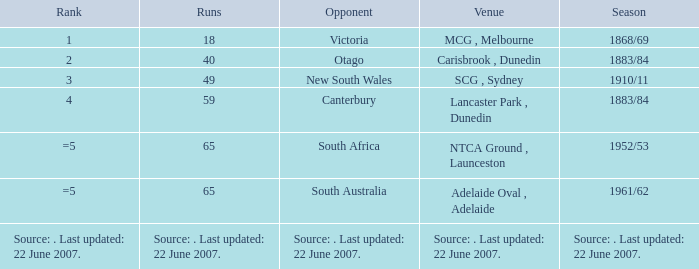In which run does canterbury appear as an adversary? 59.0. 